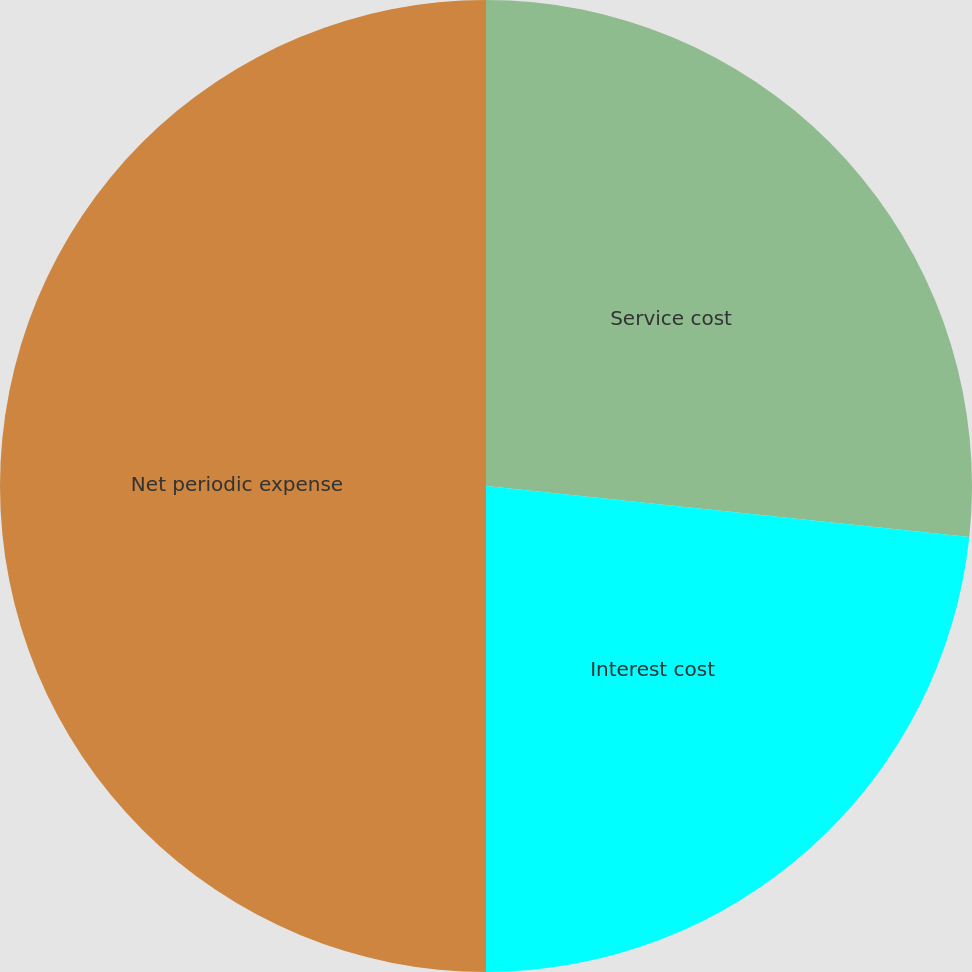<chart> <loc_0><loc_0><loc_500><loc_500><pie_chart><fcel>Service cost<fcel>Interest cost<fcel>Net periodic expense<nl><fcel>26.67%<fcel>23.33%<fcel>50.0%<nl></chart> 